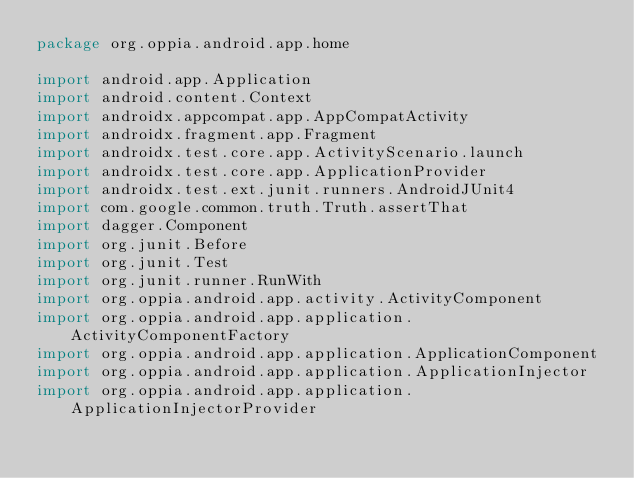Convert code to text. <code><loc_0><loc_0><loc_500><loc_500><_Kotlin_>package org.oppia.android.app.home

import android.app.Application
import android.content.Context
import androidx.appcompat.app.AppCompatActivity
import androidx.fragment.app.Fragment
import androidx.test.core.app.ActivityScenario.launch
import androidx.test.core.app.ApplicationProvider
import androidx.test.ext.junit.runners.AndroidJUnit4
import com.google.common.truth.Truth.assertThat
import dagger.Component
import org.junit.Before
import org.junit.Test
import org.junit.runner.RunWith
import org.oppia.android.app.activity.ActivityComponent
import org.oppia.android.app.application.ActivityComponentFactory
import org.oppia.android.app.application.ApplicationComponent
import org.oppia.android.app.application.ApplicationInjector
import org.oppia.android.app.application.ApplicationInjectorProvider</code> 